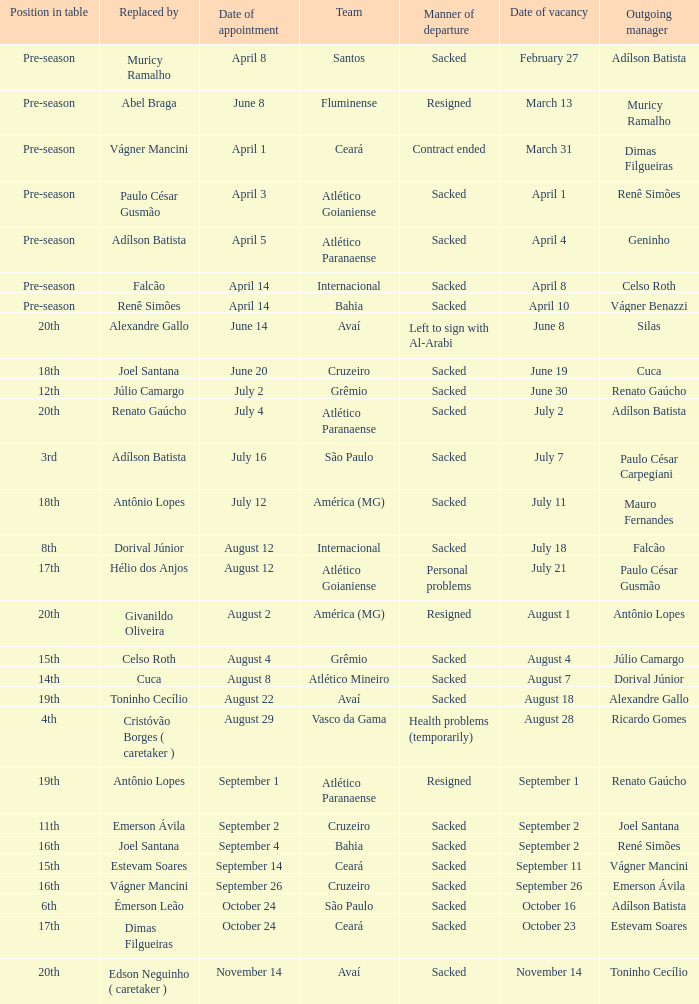How many times did Silas leave as a team manager? 1.0. 